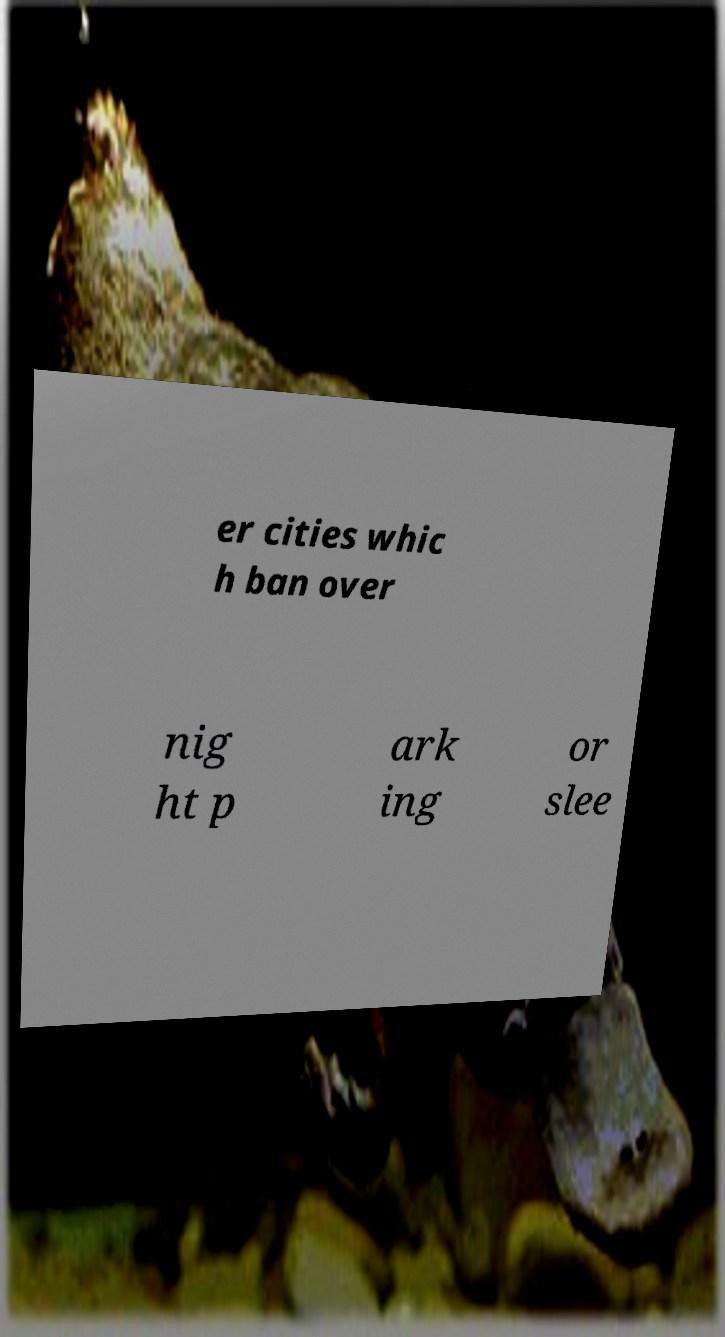I need the written content from this picture converted into text. Can you do that? er cities whic h ban over nig ht p ark ing or slee 